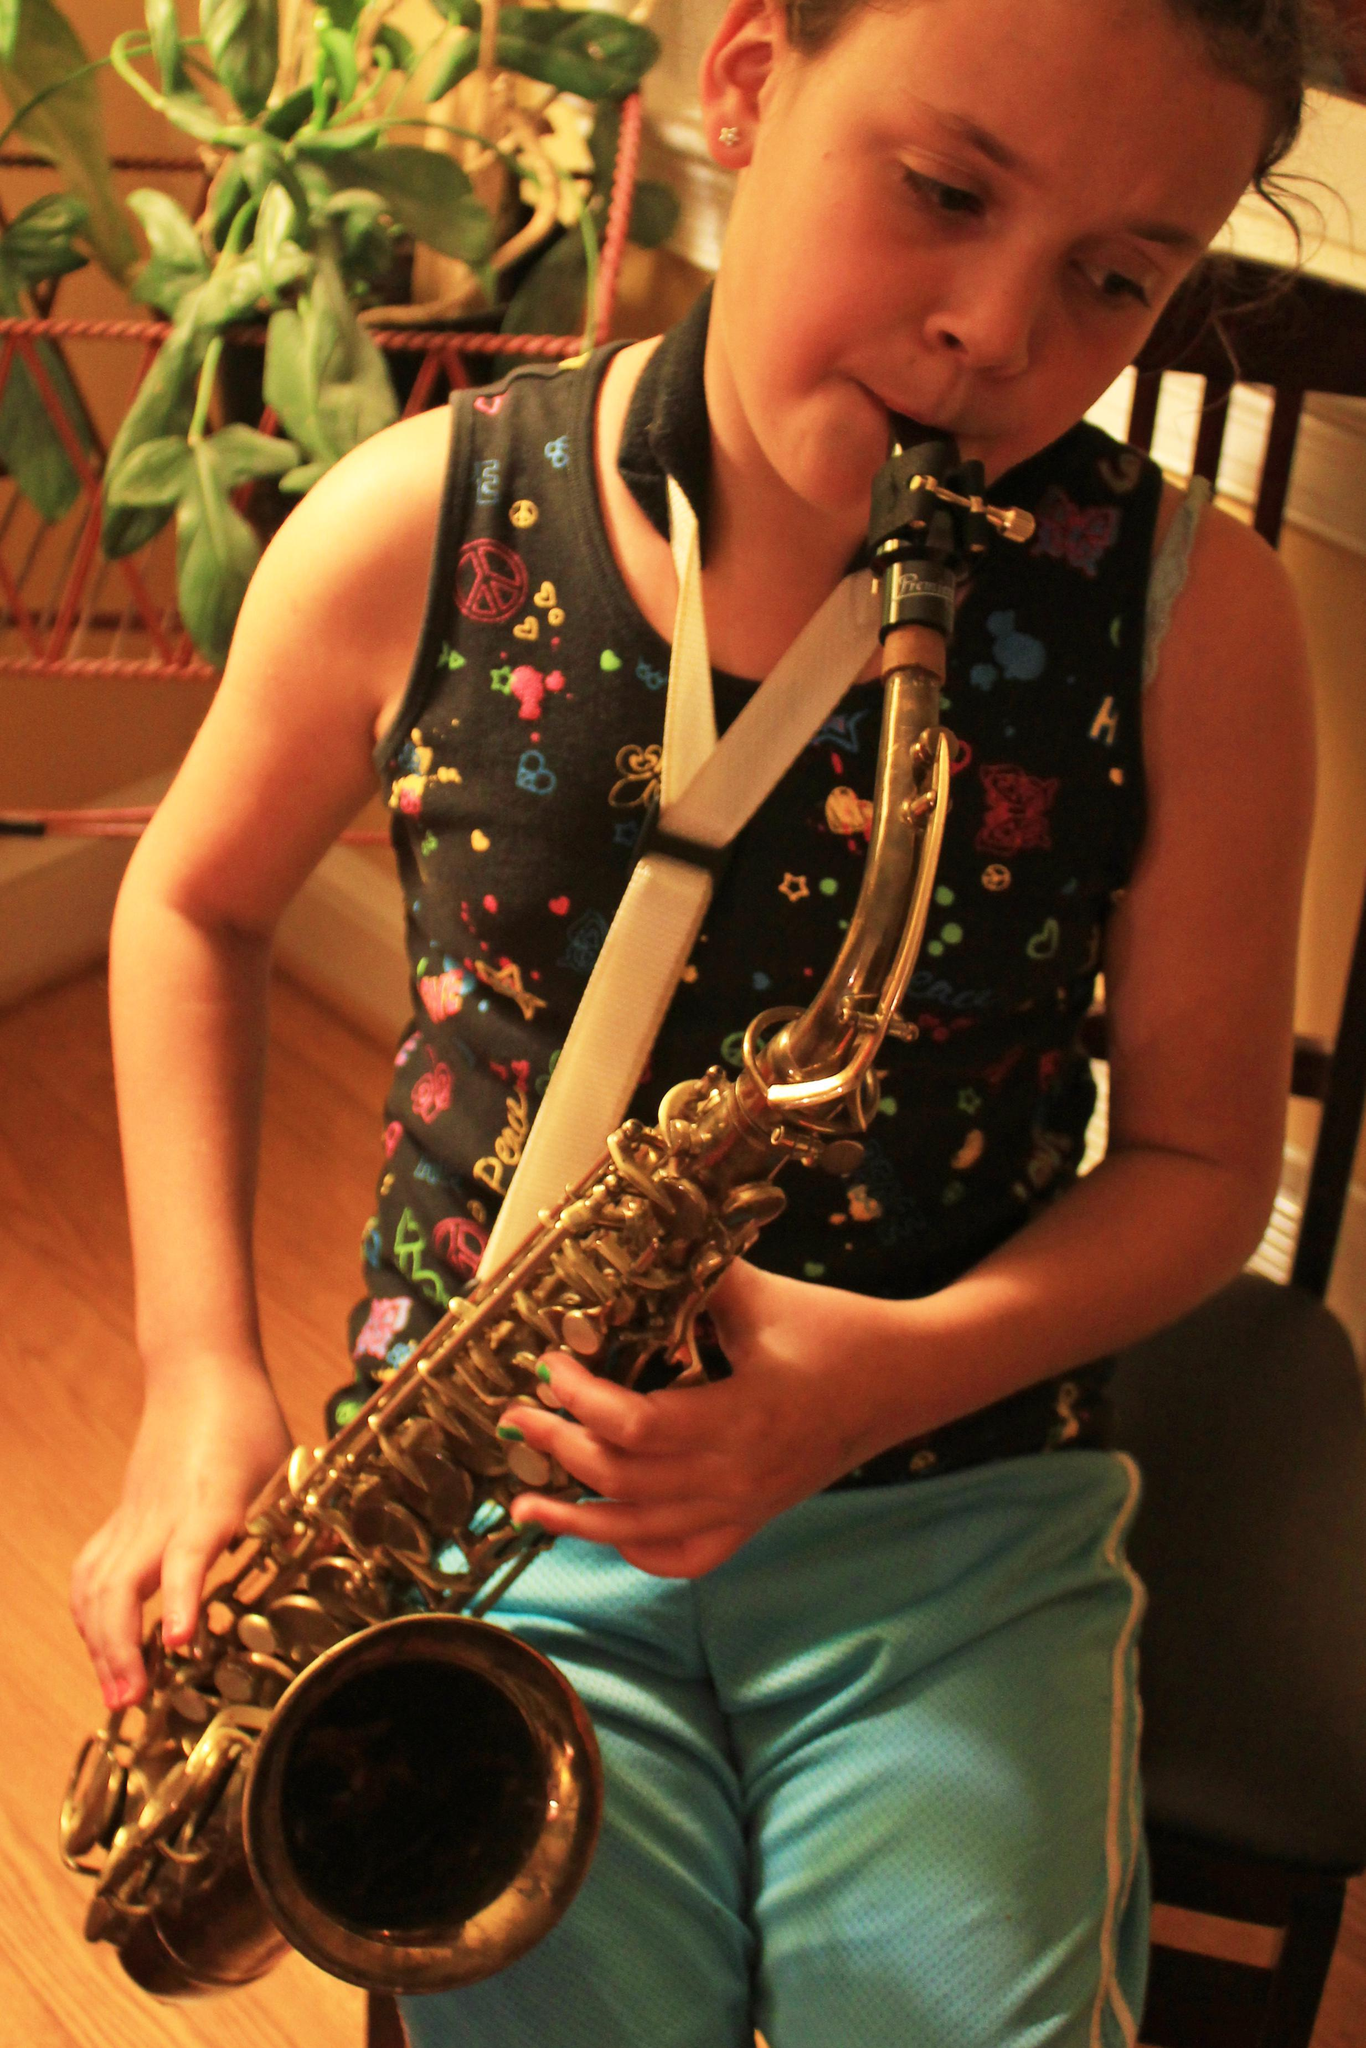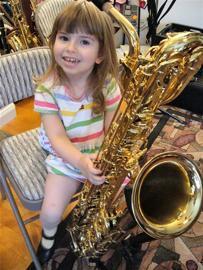The first image is the image on the left, the second image is the image on the right. Examine the images to the left and right. Is the description "Each image shows a female child holding a saxophone." accurate? Answer yes or no. Yes. The first image is the image on the left, the second image is the image on the right. Considering the images on both sides, is "The saxophone in each of the images is being played by a female child." valid? Answer yes or no. Yes. 